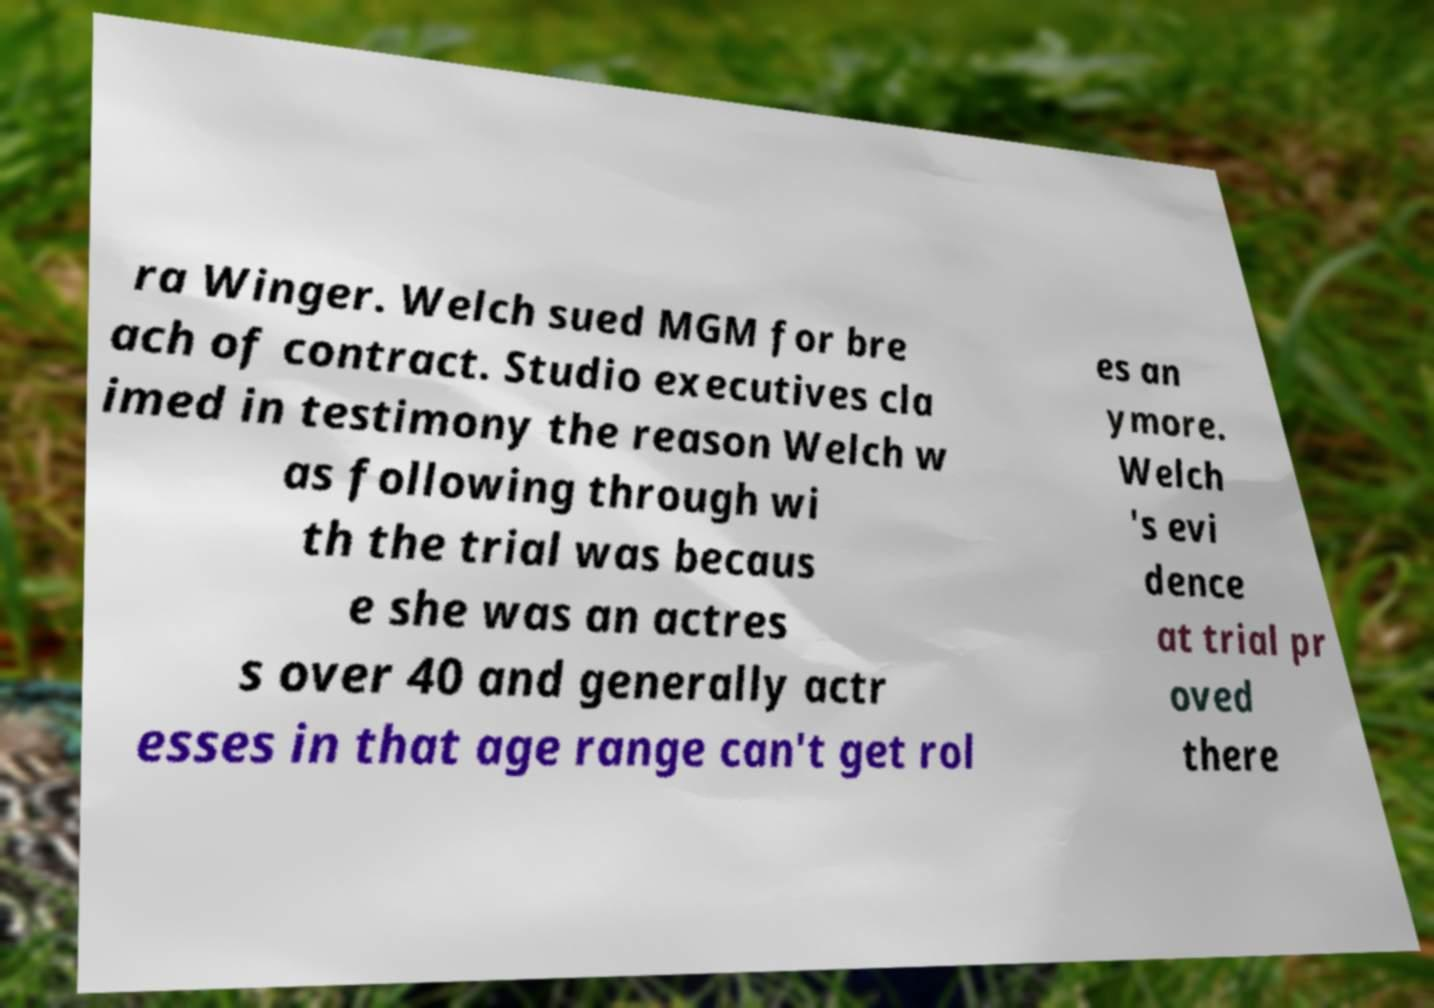Could you extract and type out the text from this image? ra Winger. Welch sued MGM for bre ach of contract. Studio executives cla imed in testimony the reason Welch w as following through wi th the trial was becaus e she was an actres s over 40 and generally actr esses in that age range can't get rol es an ymore. Welch 's evi dence at trial pr oved there 